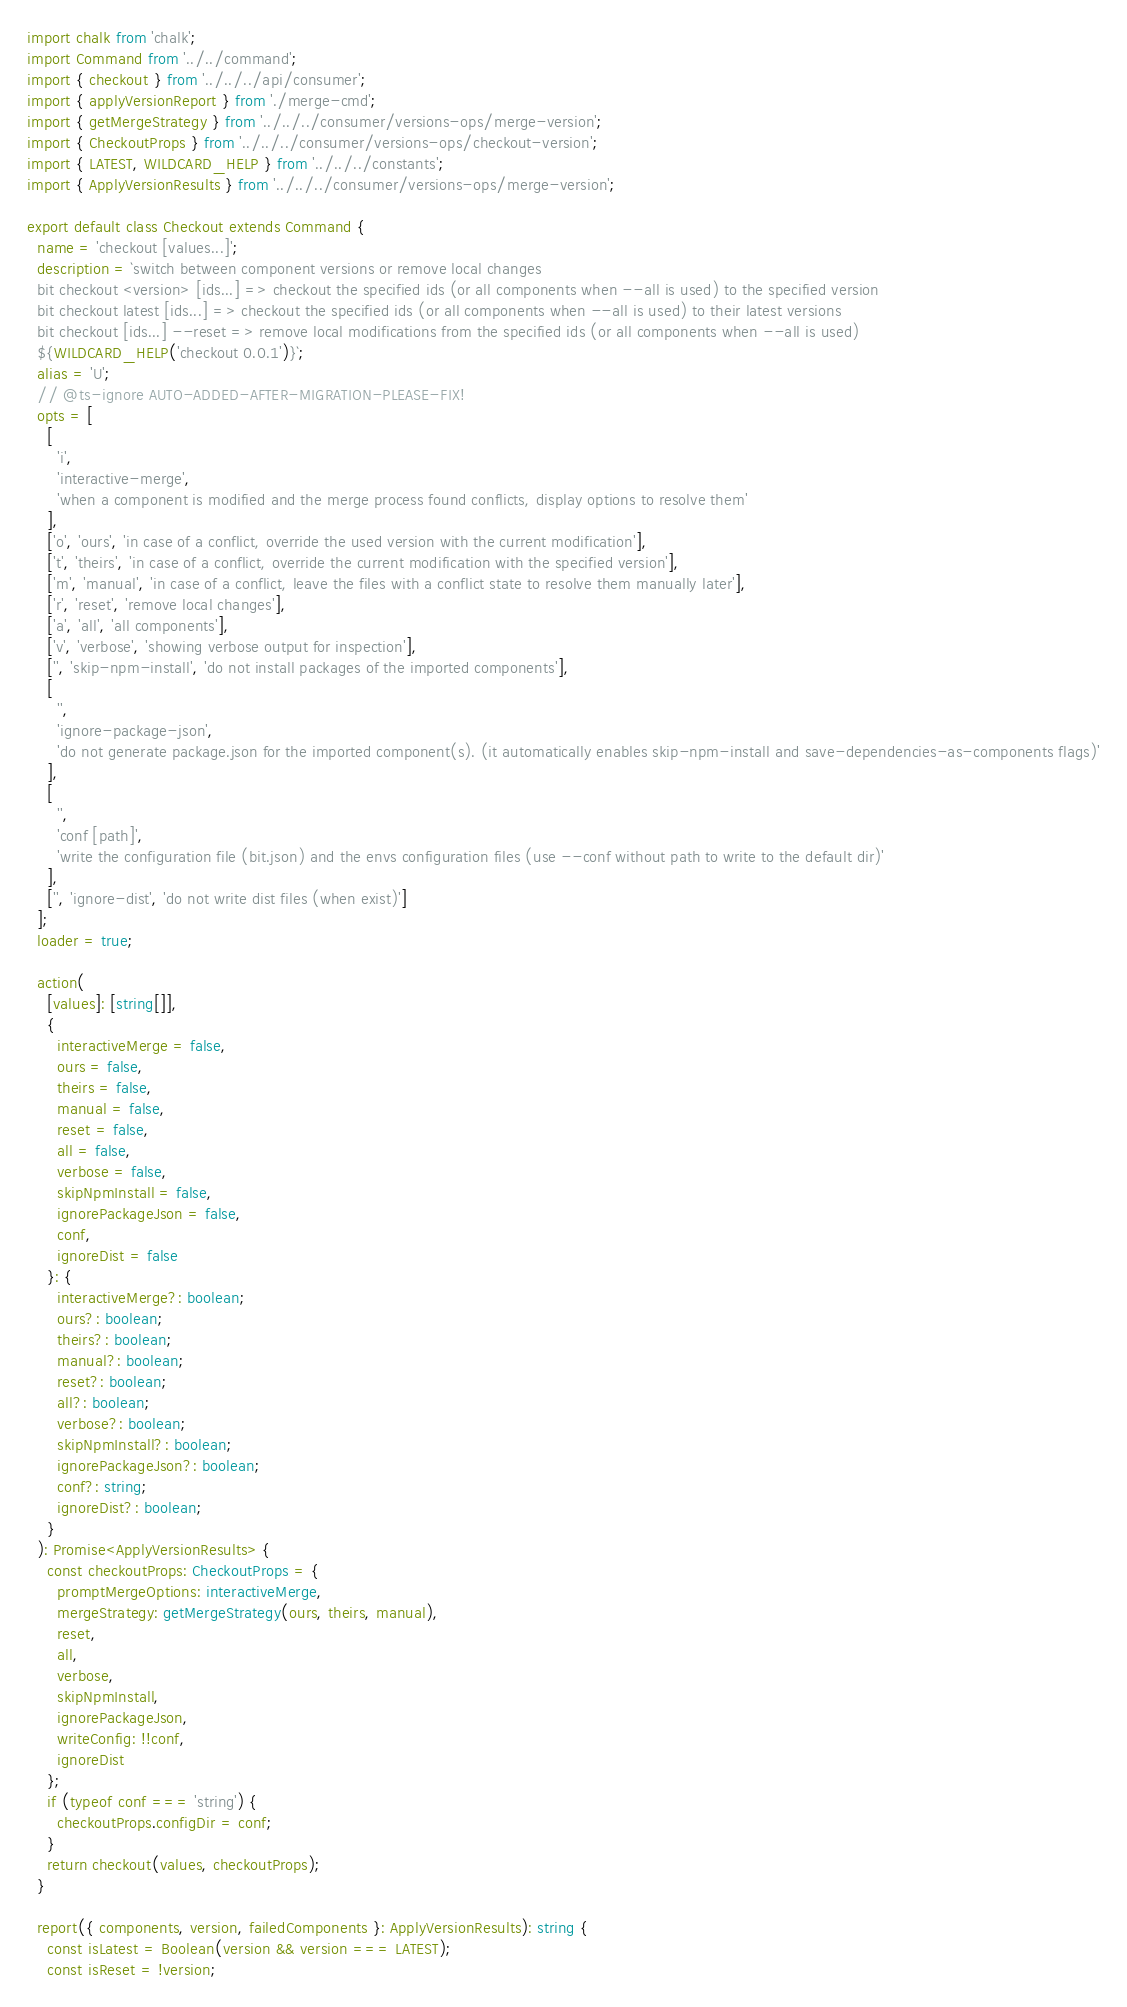Convert code to text. <code><loc_0><loc_0><loc_500><loc_500><_TypeScript_>import chalk from 'chalk';
import Command from '../../command';
import { checkout } from '../../../api/consumer';
import { applyVersionReport } from './merge-cmd';
import { getMergeStrategy } from '../../../consumer/versions-ops/merge-version';
import { CheckoutProps } from '../../../consumer/versions-ops/checkout-version';
import { LATEST, WILDCARD_HELP } from '../../../constants';
import { ApplyVersionResults } from '../../../consumer/versions-ops/merge-version';

export default class Checkout extends Command {
  name = 'checkout [values...]';
  description = `switch between component versions or remove local changes
  bit checkout <version> [ids...] => checkout the specified ids (or all components when --all is used) to the specified version
  bit checkout latest [ids...] => checkout the specified ids (or all components when --all is used) to their latest versions
  bit checkout [ids...] --reset => remove local modifications from the specified ids (or all components when --all is used)
  ${WILDCARD_HELP('checkout 0.0.1')}`;
  alias = 'U';
  // @ts-ignore AUTO-ADDED-AFTER-MIGRATION-PLEASE-FIX!
  opts = [
    [
      'i',
      'interactive-merge',
      'when a component is modified and the merge process found conflicts, display options to resolve them'
    ],
    ['o', 'ours', 'in case of a conflict, override the used version with the current modification'],
    ['t', 'theirs', 'in case of a conflict, override the current modification with the specified version'],
    ['m', 'manual', 'in case of a conflict, leave the files with a conflict state to resolve them manually later'],
    ['r', 'reset', 'remove local changes'],
    ['a', 'all', 'all components'],
    ['v', 'verbose', 'showing verbose output for inspection'],
    ['', 'skip-npm-install', 'do not install packages of the imported components'],
    [
      '',
      'ignore-package-json',
      'do not generate package.json for the imported component(s). (it automatically enables skip-npm-install and save-dependencies-as-components flags)'
    ],
    [
      '',
      'conf [path]',
      'write the configuration file (bit.json) and the envs configuration files (use --conf without path to write to the default dir)'
    ],
    ['', 'ignore-dist', 'do not write dist files (when exist)']
  ];
  loader = true;

  action(
    [values]: [string[]],
    {
      interactiveMerge = false,
      ours = false,
      theirs = false,
      manual = false,
      reset = false,
      all = false,
      verbose = false,
      skipNpmInstall = false,
      ignorePackageJson = false,
      conf,
      ignoreDist = false
    }: {
      interactiveMerge?: boolean;
      ours?: boolean;
      theirs?: boolean;
      manual?: boolean;
      reset?: boolean;
      all?: boolean;
      verbose?: boolean;
      skipNpmInstall?: boolean;
      ignorePackageJson?: boolean;
      conf?: string;
      ignoreDist?: boolean;
    }
  ): Promise<ApplyVersionResults> {
    const checkoutProps: CheckoutProps = {
      promptMergeOptions: interactiveMerge,
      mergeStrategy: getMergeStrategy(ours, theirs, manual),
      reset,
      all,
      verbose,
      skipNpmInstall,
      ignorePackageJson,
      writeConfig: !!conf,
      ignoreDist
    };
    if (typeof conf === 'string') {
      checkoutProps.configDir = conf;
    }
    return checkout(values, checkoutProps);
  }

  report({ components, version, failedComponents }: ApplyVersionResults): string {
    const isLatest = Boolean(version && version === LATEST);
    const isReset = !version;</code> 